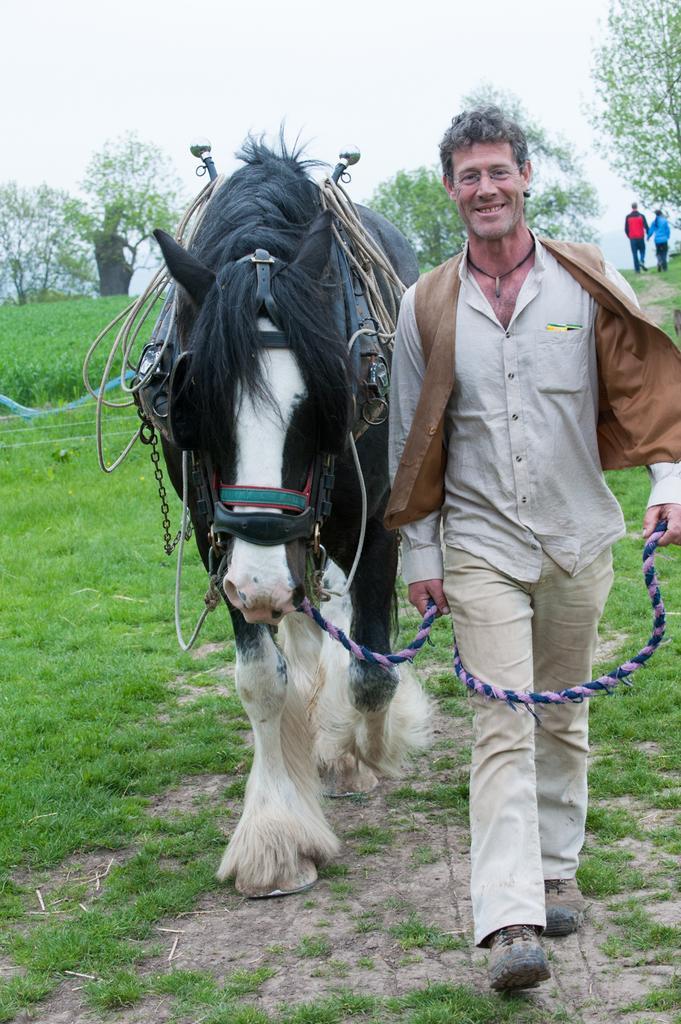Could you give a brief overview of what you see in this image? In this image we can see a man on the right side is walking on the ground by holding a rope in his hand which is tied to the horse and it is also walking on the ground. In the background we can see trees, two persons walking on the ground, plants, grass and sky. 